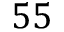Convert formula to latex. <formula><loc_0><loc_0><loc_500><loc_500>5 5</formula> 